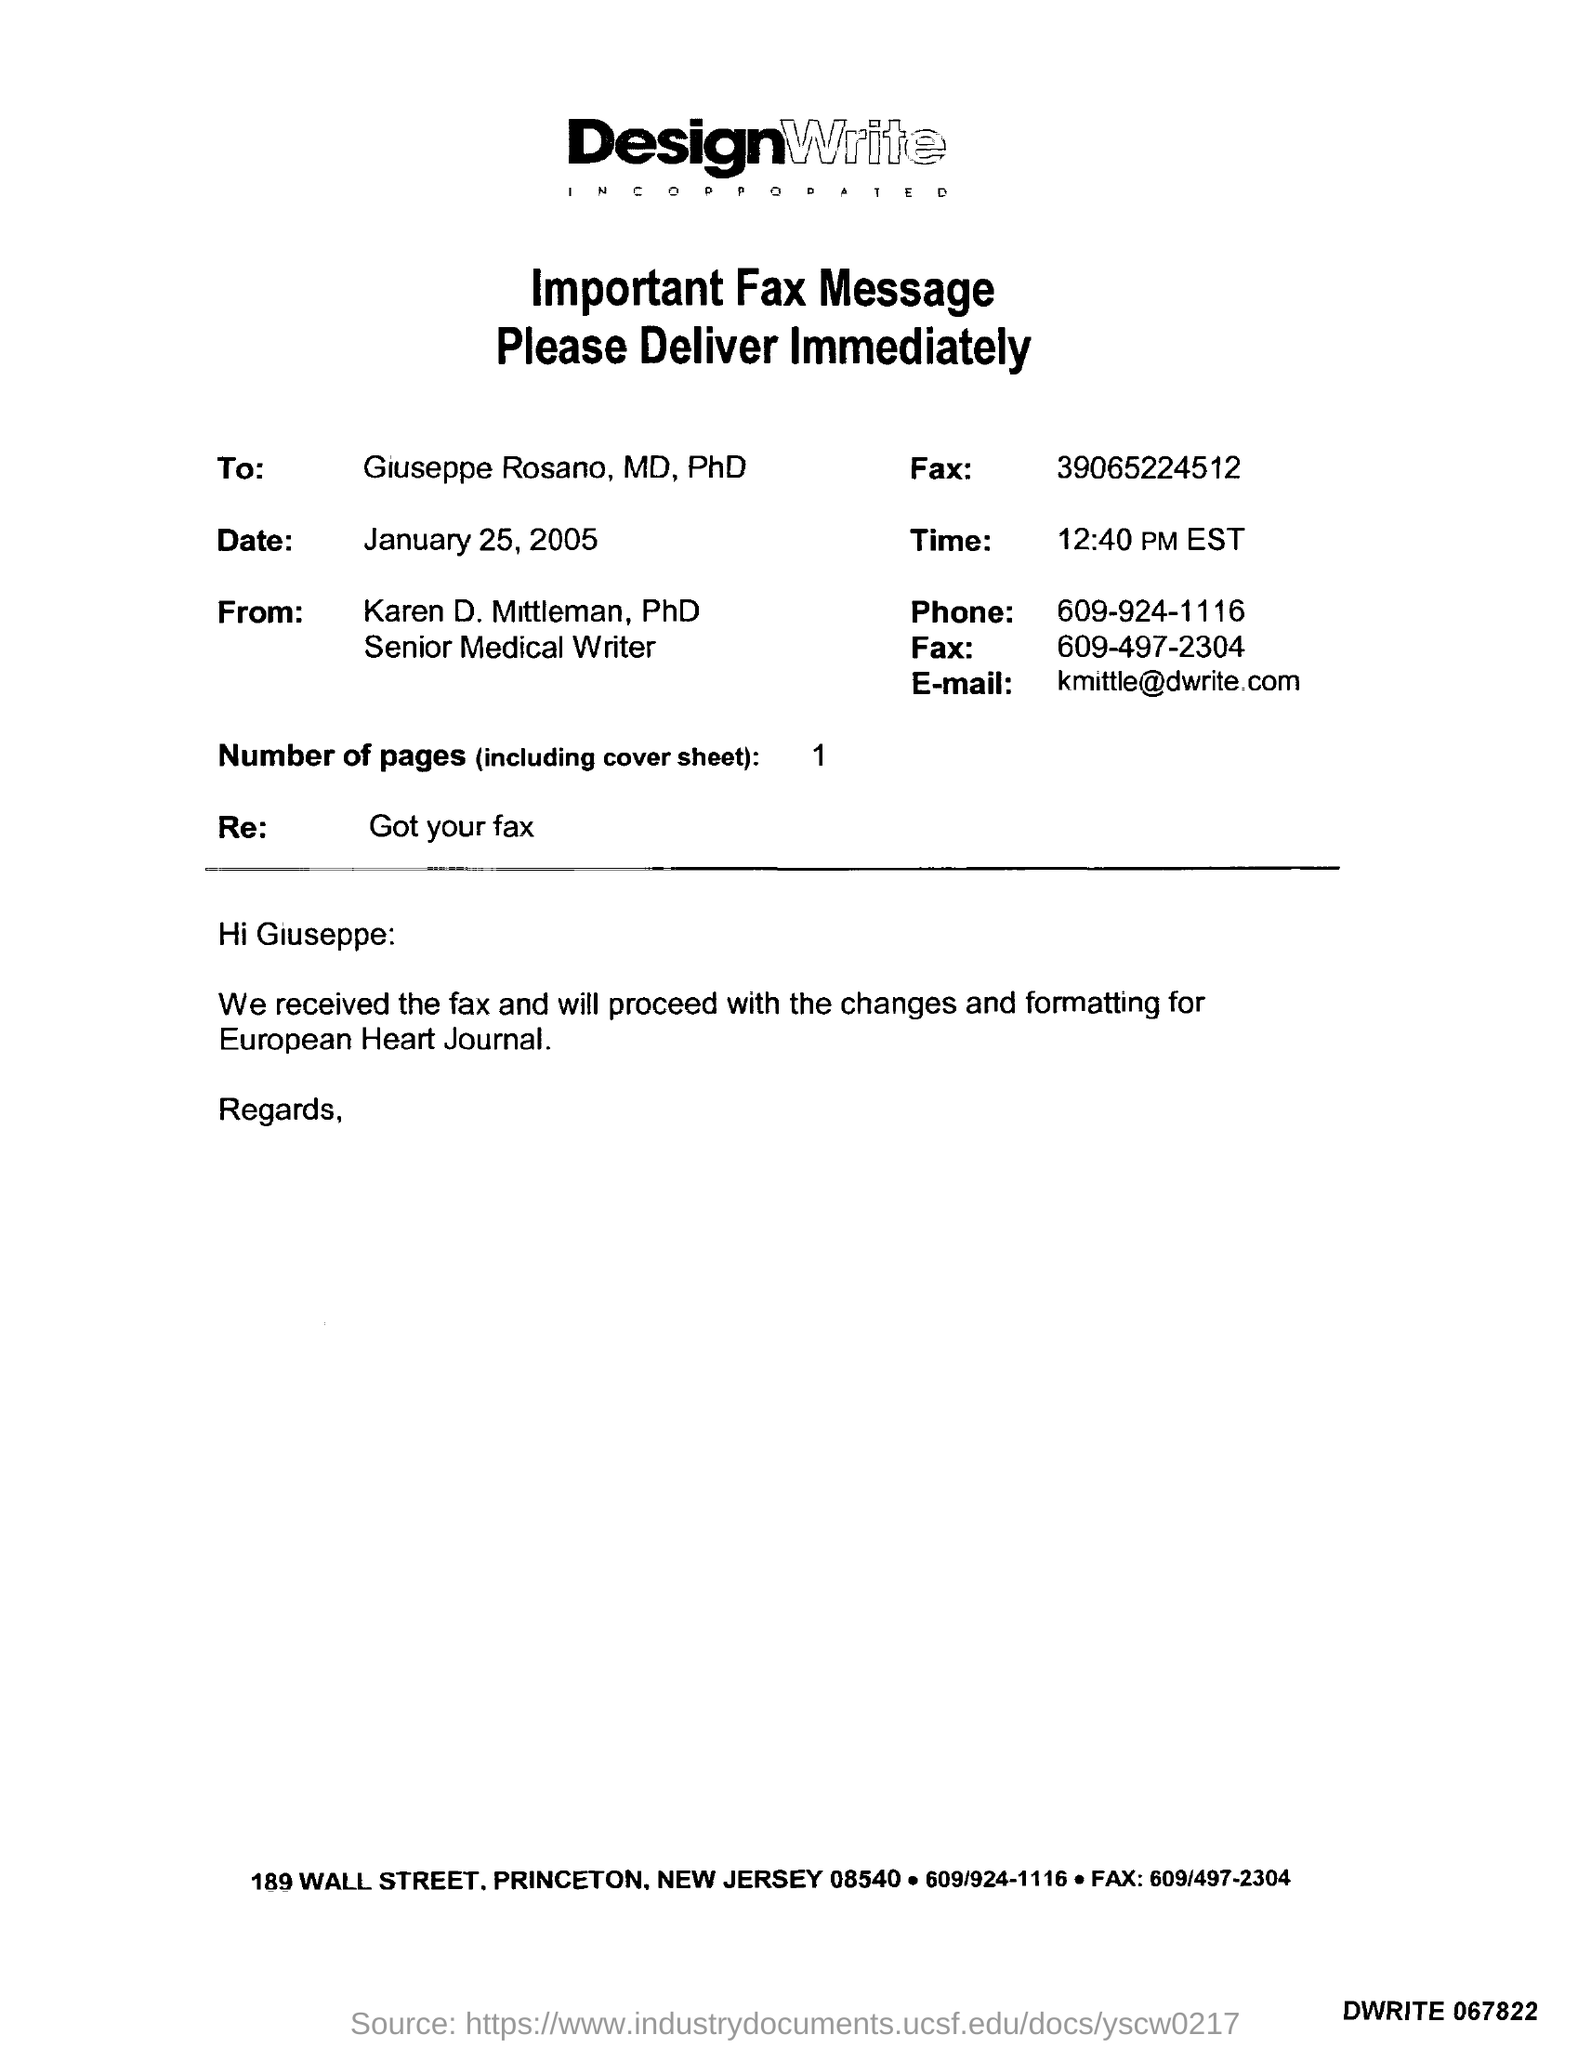What is the Phone number?
Provide a short and direct response. 609-924-1116. What is the Email id?
Ensure brevity in your answer.  Kmittle@dwrite.com. What is the number of pages?
Make the answer very short. 1. 